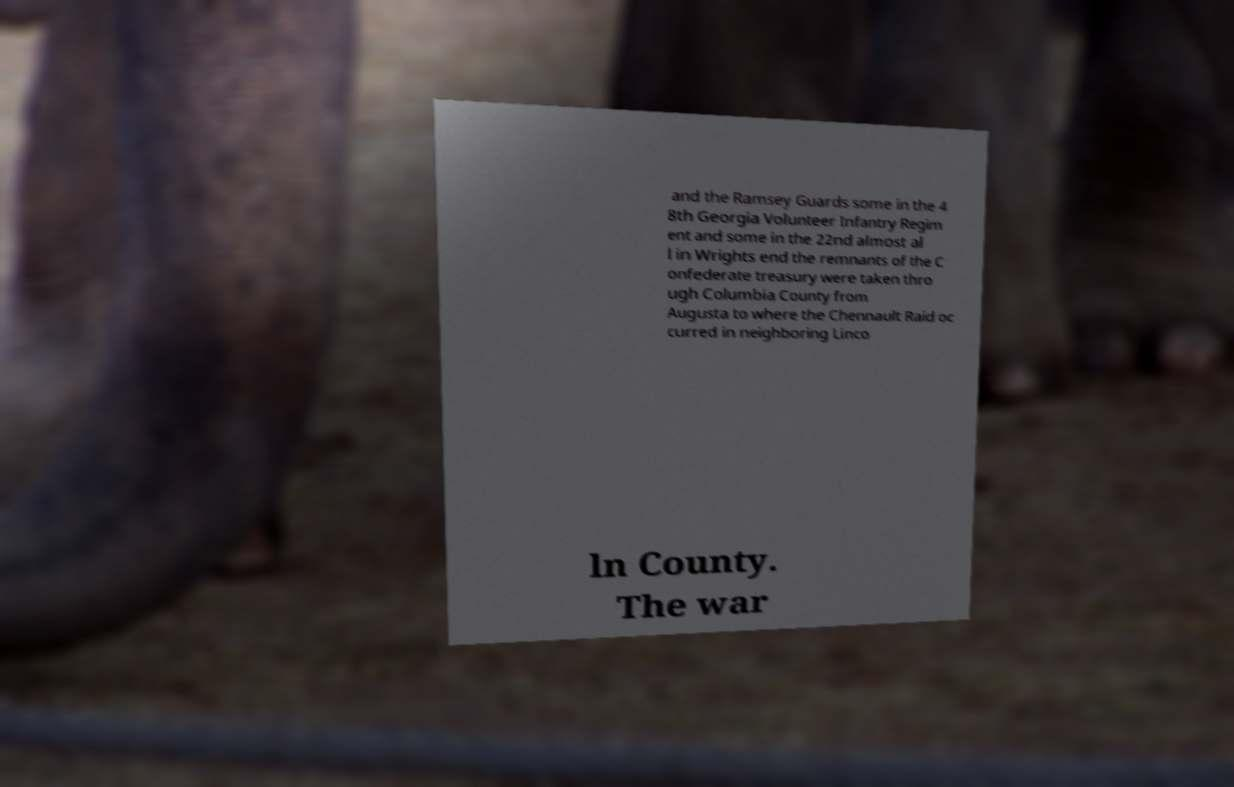There's text embedded in this image that I need extracted. Can you transcribe it verbatim? and the Ramsey Guards some in the 4 8th Georgia Volunteer Infantry Regim ent and some in the 22nd almost al l in Wrights end the remnants of the C onfederate treasury were taken thro ugh Columbia County from Augusta to where the Chennault Raid oc curred in neighboring Linco ln County. The war 